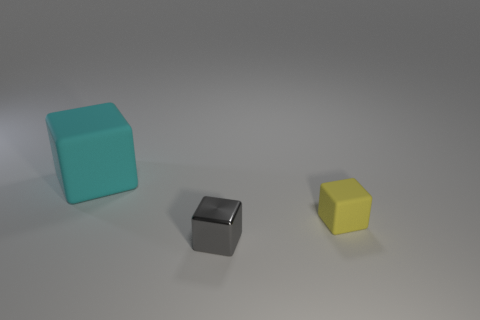Add 1 matte objects. How many objects exist? 4 Add 3 cyan blocks. How many cyan blocks exist? 4 Subtract 1 gray blocks. How many objects are left? 2 Subtract all yellow rubber things. Subtract all big cyan matte blocks. How many objects are left? 1 Add 2 small objects. How many small objects are left? 4 